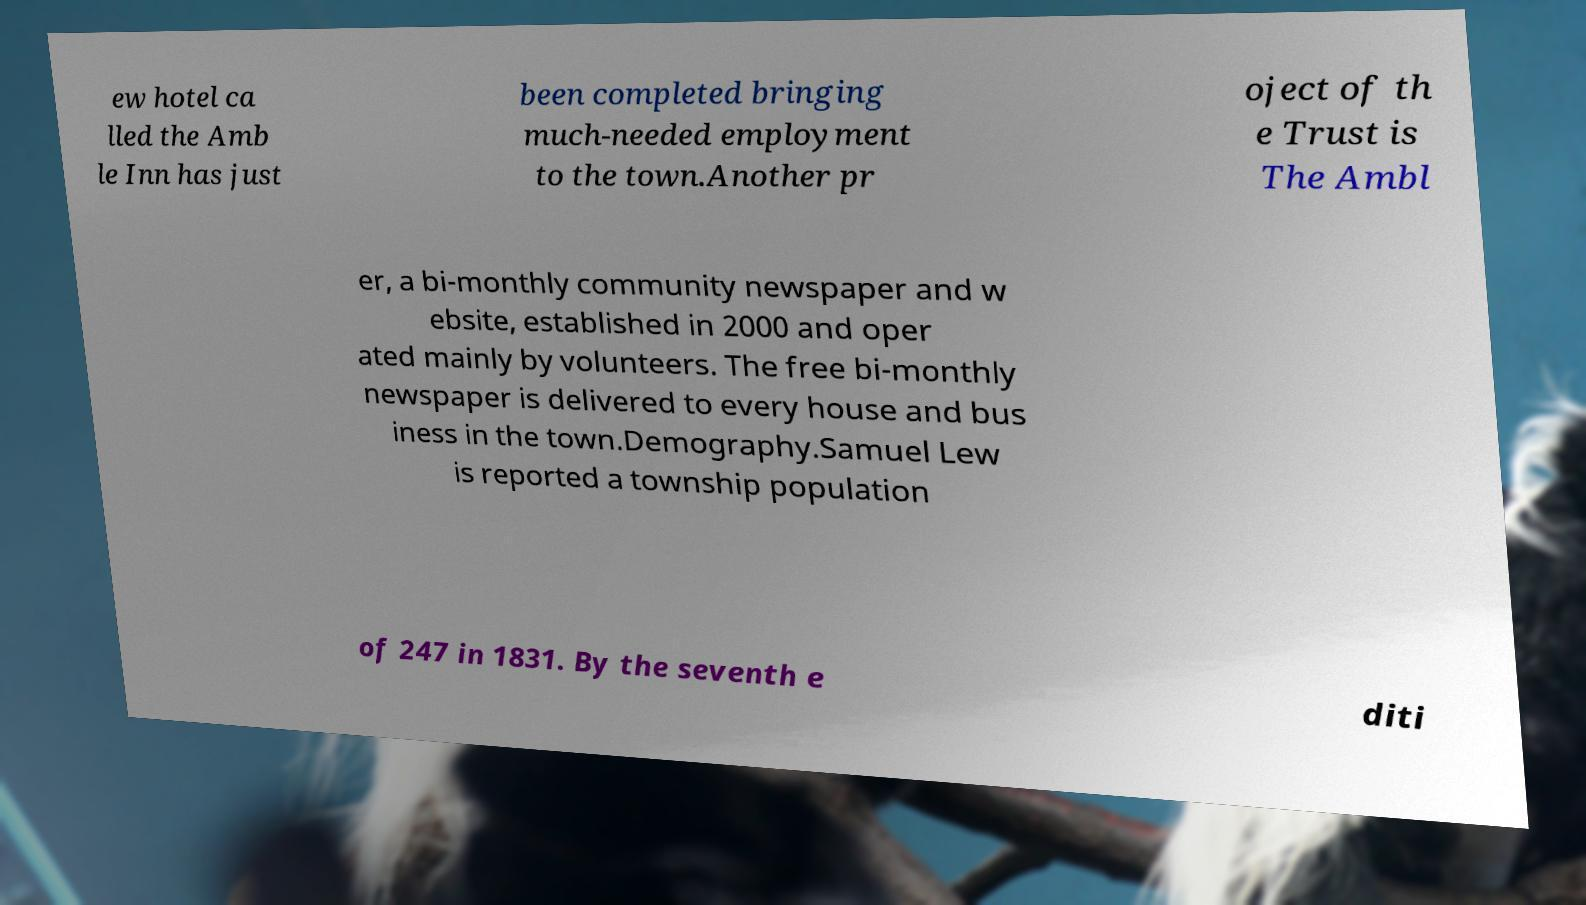For documentation purposes, I need the text within this image transcribed. Could you provide that? ew hotel ca lled the Amb le Inn has just been completed bringing much-needed employment to the town.Another pr oject of th e Trust is The Ambl er, a bi-monthly community newspaper and w ebsite, established in 2000 and oper ated mainly by volunteers. The free bi-monthly newspaper is delivered to every house and bus iness in the town.Demography.Samuel Lew is reported a township population of 247 in 1831. By the seventh e diti 